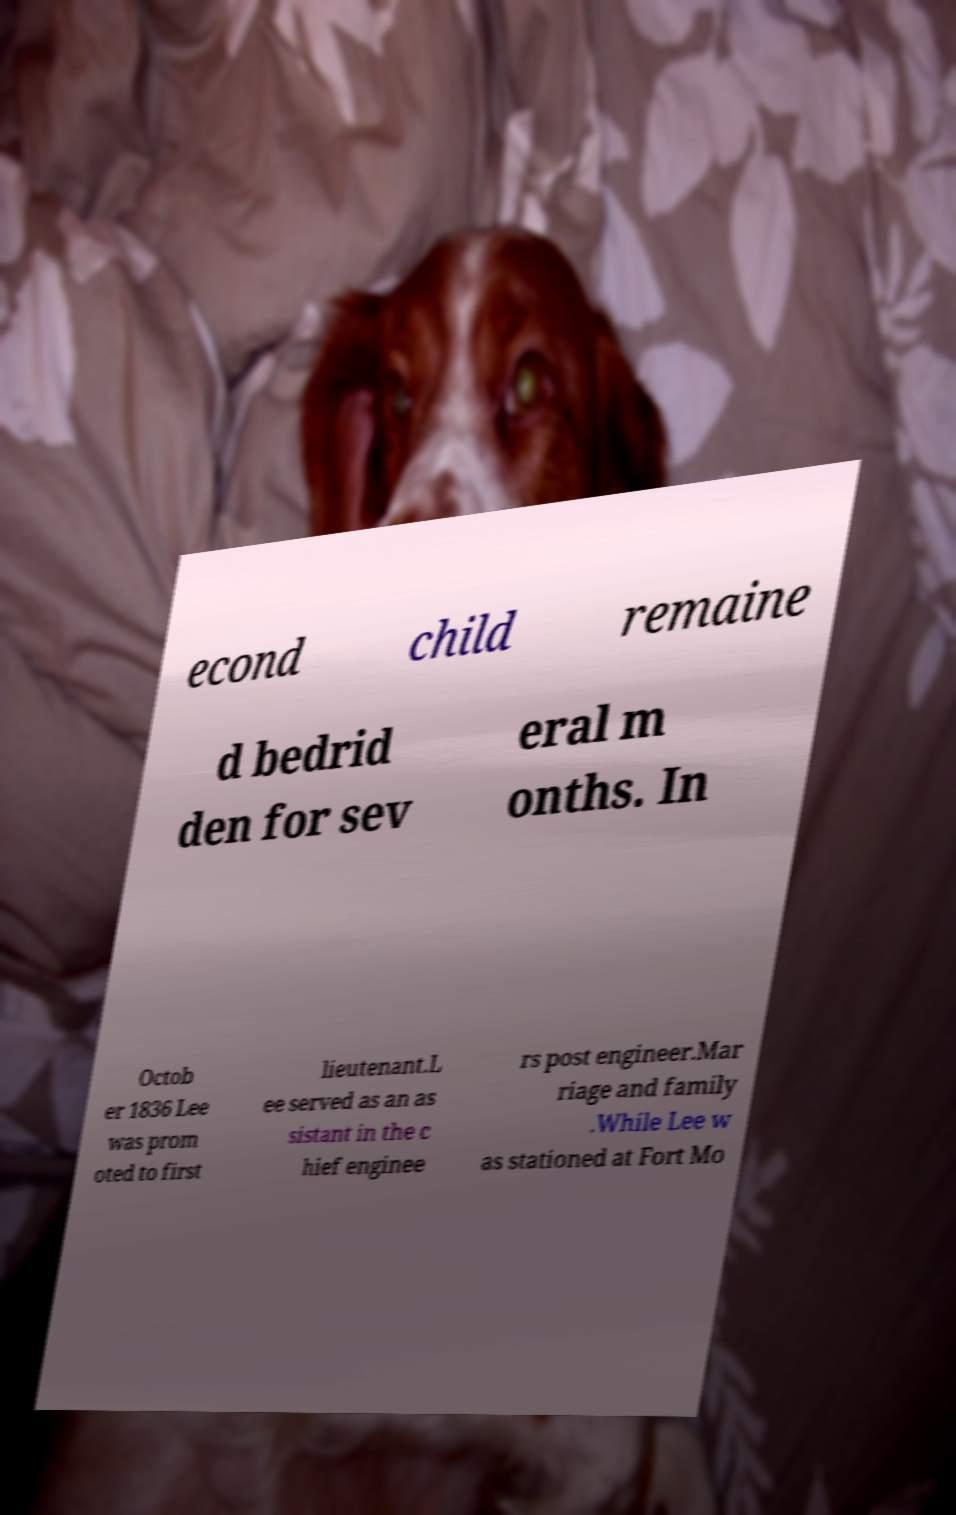Please read and relay the text visible in this image. What does it say? econd child remaine d bedrid den for sev eral m onths. In Octob er 1836 Lee was prom oted to first lieutenant.L ee served as an as sistant in the c hief enginee rs post engineer.Mar riage and family .While Lee w as stationed at Fort Mo 